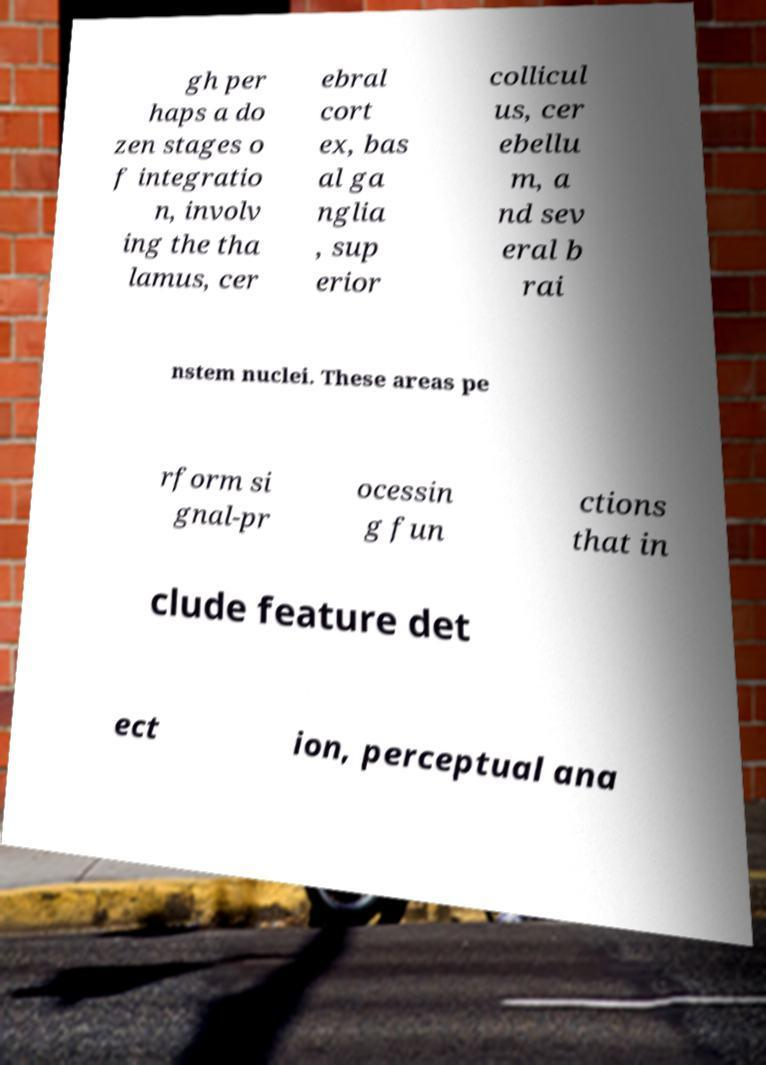Can you read and provide the text displayed in the image?This photo seems to have some interesting text. Can you extract and type it out for me? gh per haps a do zen stages o f integratio n, involv ing the tha lamus, cer ebral cort ex, bas al ga nglia , sup erior collicul us, cer ebellu m, a nd sev eral b rai nstem nuclei. These areas pe rform si gnal-pr ocessin g fun ctions that in clude feature det ect ion, perceptual ana 